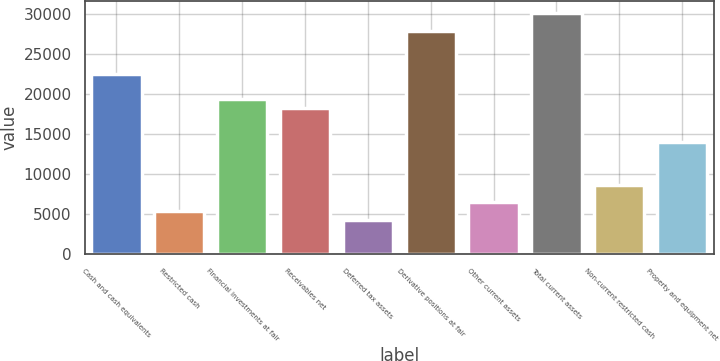Convert chart. <chart><loc_0><loc_0><loc_500><loc_500><bar_chart><fcel>Cash and cash equivalents<fcel>Restricted cash<fcel>Financial investments at fair<fcel>Receivables net<fcel>Deferred tax assets<fcel>Derivative positions at fair<fcel>Other current assets<fcel>Total current assets<fcel>Non-current restricted cash<fcel>Property and equipment net<nl><fcel>22514<fcel>5362<fcel>19298<fcel>18226<fcel>4290<fcel>27874<fcel>6434<fcel>30018<fcel>8578<fcel>13938<nl></chart> 